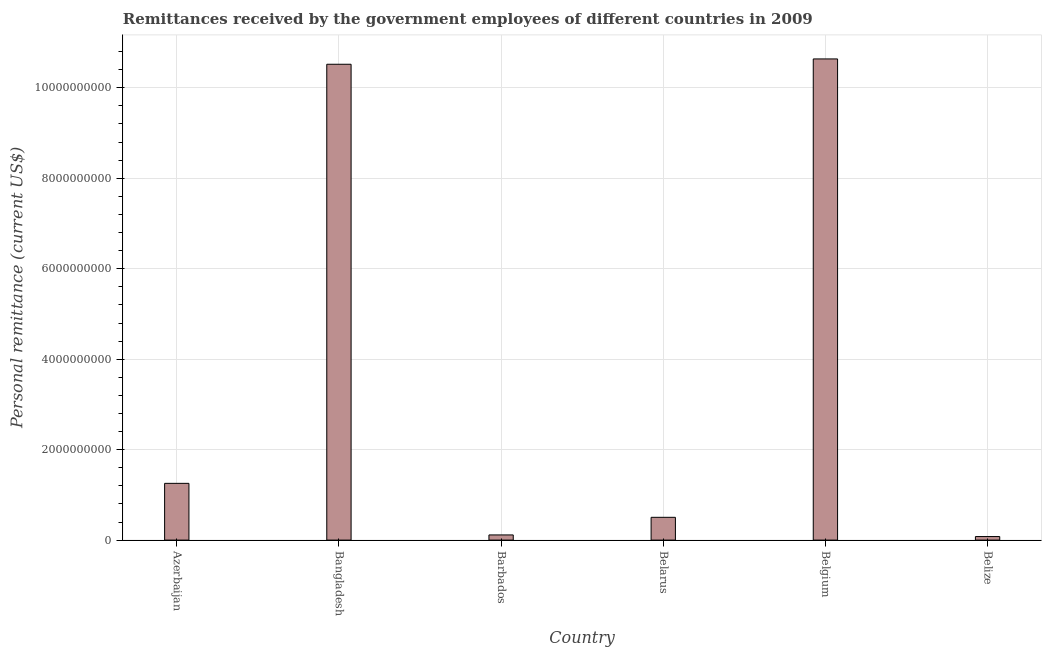Does the graph contain any zero values?
Give a very brief answer. No. What is the title of the graph?
Offer a very short reply. Remittances received by the government employees of different countries in 2009. What is the label or title of the Y-axis?
Provide a succinct answer. Personal remittance (current US$). What is the personal remittances in Belize?
Ensure brevity in your answer.  7.86e+07. Across all countries, what is the maximum personal remittances?
Offer a very short reply. 1.06e+1. Across all countries, what is the minimum personal remittances?
Keep it short and to the point. 7.86e+07. In which country was the personal remittances minimum?
Provide a short and direct response. Belize. What is the sum of the personal remittances?
Give a very brief answer. 2.31e+1. What is the difference between the personal remittances in Azerbaijan and Bangladesh?
Offer a terse response. -9.27e+09. What is the average personal remittances per country?
Ensure brevity in your answer.  3.85e+09. What is the median personal remittances?
Offer a terse response. 8.79e+08. What is the ratio of the personal remittances in Bangladesh to that in Belize?
Ensure brevity in your answer.  133.89. Is the difference between the personal remittances in Azerbaijan and Bangladesh greater than the difference between any two countries?
Provide a short and direct response. No. What is the difference between the highest and the second highest personal remittances?
Provide a short and direct response. 1.18e+08. Is the sum of the personal remittances in Belarus and Belize greater than the maximum personal remittances across all countries?
Provide a succinct answer. No. What is the difference between the highest and the lowest personal remittances?
Your response must be concise. 1.06e+1. In how many countries, is the personal remittances greater than the average personal remittances taken over all countries?
Offer a terse response. 2. How many bars are there?
Your response must be concise. 6. How many countries are there in the graph?
Your response must be concise. 6. Are the values on the major ticks of Y-axis written in scientific E-notation?
Make the answer very short. No. What is the Personal remittance (current US$) in Azerbaijan?
Make the answer very short. 1.25e+09. What is the Personal remittance (current US$) of Bangladesh?
Make the answer very short. 1.05e+1. What is the Personal remittance (current US$) of Barbados?
Make the answer very short. 1.14e+08. What is the Personal remittance (current US$) in Belarus?
Provide a short and direct response. 5.04e+08. What is the Personal remittance (current US$) in Belgium?
Offer a very short reply. 1.06e+1. What is the Personal remittance (current US$) of Belize?
Provide a succinct answer. 7.86e+07. What is the difference between the Personal remittance (current US$) in Azerbaijan and Bangladesh?
Ensure brevity in your answer.  -9.27e+09. What is the difference between the Personal remittance (current US$) in Azerbaijan and Barbados?
Your answer should be very brief. 1.14e+09. What is the difference between the Personal remittance (current US$) in Azerbaijan and Belarus?
Your answer should be very brief. 7.51e+08. What is the difference between the Personal remittance (current US$) in Azerbaijan and Belgium?
Offer a very short reply. -9.38e+09. What is the difference between the Personal remittance (current US$) in Azerbaijan and Belize?
Keep it short and to the point. 1.18e+09. What is the difference between the Personal remittance (current US$) in Bangladesh and Barbados?
Give a very brief answer. 1.04e+1. What is the difference between the Personal remittance (current US$) in Bangladesh and Belarus?
Provide a short and direct response. 1.00e+1. What is the difference between the Personal remittance (current US$) in Bangladesh and Belgium?
Ensure brevity in your answer.  -1.18e+08. What is the difference between the Personal remittance (current US$) in Bangladesh and Belize?
Your answer should be compact. 1.04e+1. What is the difference between the Personal remittance (current US$) in Barbados and Belarus?
Give a very brief answer. -3.89e+08. What is the difference between the Personal remittance (current US$) in Barbados and Belgium?
Provide a succinct answer. -1.05e+1. What is the difference between the Personal remittance (current US$) in Barbados and Belize?
Make the answer very short. 3.59e+07. What is the difference between the Personal remittance (current US$) in Belarus and Belgium?
Offer a terse response. -1.01e+1. What is the difference between the Personal remittance (current US$) in Belarus and Belize?
Ensure brevity in your answer.  4.25e+08. What is the difference between the Personal remittance (current US$) in Belgium and Belize?
Provide a short and direct response. 1.06e+1. What is the ratio of the Personal remittance (current US$) in Azerbaijan to that in Bangladesh?
Keep it short and to the point. 0.12. What is the ratio of the Personal remittance (current US$) in Azerbaijan to that in Barbados?
Your answer should be very brief. 10.96. What is the ratio of the Personal remittance (current US$) in Azerbaijan to that in Belarus?
Your response must be concise. 2.49. What is the ratio of the Personal remittance (current US$) in Azerbaijan to that in Belgium?
Your answer should be very brief. 0.12. What is the ratio of the Personal remittance (current US$) in Azerbaijan to that in Belize?
Your answer should be very brief. 15.97. What is the ratio of the Personal remittance (current US$) in Bangladesh to that in Barbados?
Provide a short and direct response. 91.9. What is the ratio of the Personal remittance (current US$) in Bangladesh to that in Belarus?
Offer a terse response. 20.88. What is the ratio of the Personal remittance (current US$) in Bangladesh to that in Belgium?
Your response must be concise. 0.99. What is the ratio of the Personal remittance (current US$) in Bangladesh to that in Belize?
Keep it short and to the point. 133.89. What is the ratio of the Personal remittance (current US$) in Barbados to that in Belarus?
Ensure brevity in your answer.  0.23. What is the ratio of the Personal remittance (current US$) in Barbados to that in Belgium?
Make the answer very short. 0.01. What is the ratio of the Personal remittance (current US$) in Barbados to that in Belize?
Provide a short and direct response. 1.46. What is the ratio of the Personal remittance (current US$) in Belarus to that in Belgium?
Provide a succinct answer. 0.05. What is the ratio of the Personal remittance (current US$) in Belarus to that in Belize?
Give a very brief answer. 6.41. What is the ratio of the Personal remittance (current US$) in Belgium to that in Belize?
Offer a very short reply. 135.39. 